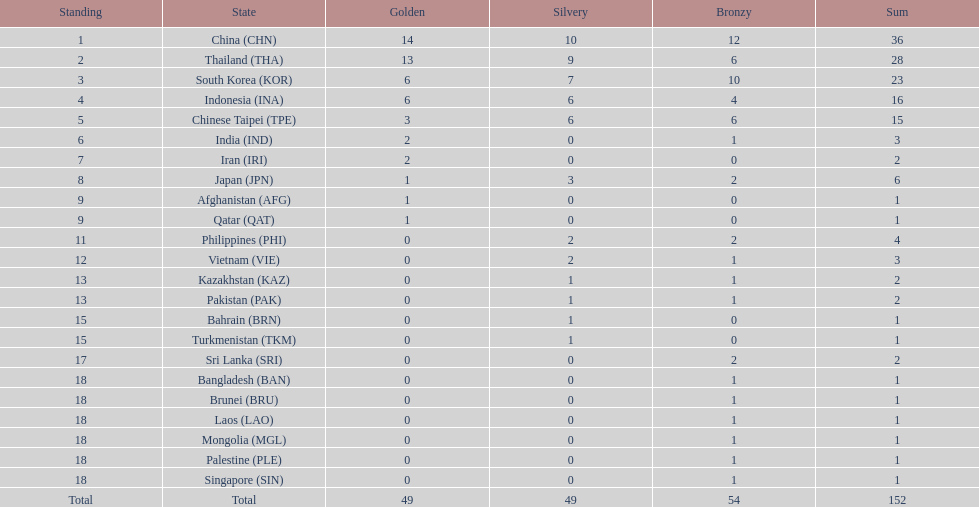Did the philippines or kazakhstan have a higher number of total medals? Philippines. 